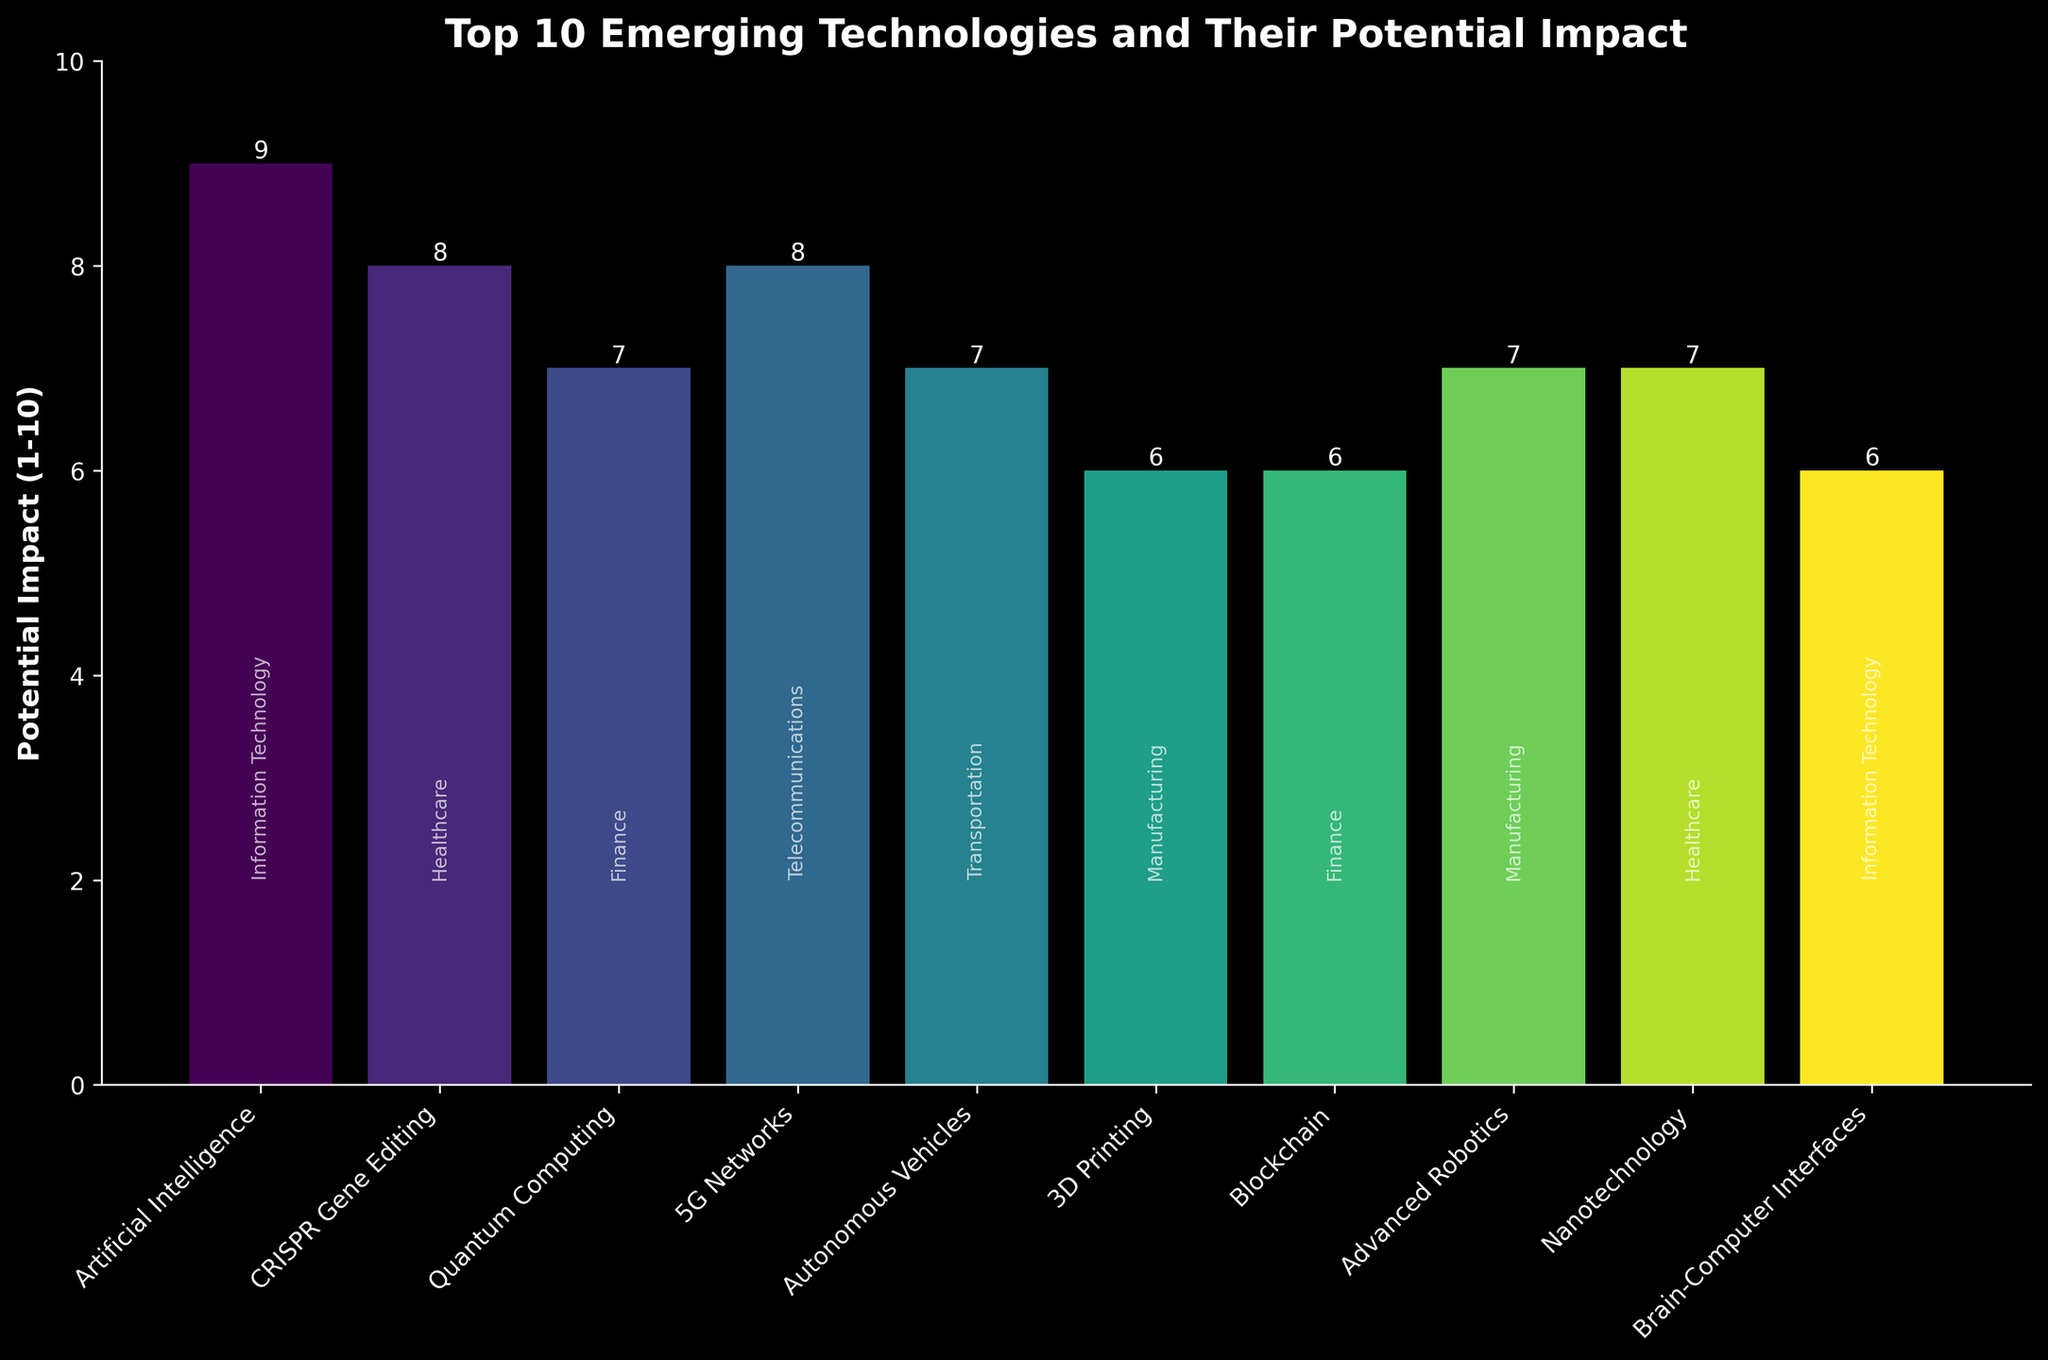Which technology is shown to have the highest potential impact? The figure shows the height of each bar representing the potential impact of each technology. The bar for Artificial Intelligence is the tallest, indicating the highest impact.
Answer: Artificial Intelligence Which primary industry is affected by both the technology with the highest and the lowest impact? To determine this, identify the technology with the highest (Artificial Intelligence) and lowest (3D Printing, Brain-Computer Interfaces, Blockchain) impact from the chart and check the associated industries. "Information Technology" is the industry for Artificial Intelligence and Brain-Computer Interfaces.
Answer: Information Technology What is the difference in potential impact between CRISPR Gene Editing and Quantum Computing? CRISPR Gene Editing has a potential impact value of 8, and Quantum Computing has a value of 7. Therefore, the difference is 8 - 7.
Answer: 1 Which industry appears frequently among the top 10 emerging technologies? The chart labels industries next to each bar. By counting, "Healthcare" appears twice (CRISPR Gene Editing and Nanotechnology) and "Manufacturing" appears twice (3D Printing and Advanced Robotics).
Answer: Healthcare and Manufacturing How many technologies have an impact score of 7? Count the number of bars that have a height of 7. These are Quantum Computing, Autonomous Vehicles, Advanced Robotics, and Nanotechnology.
Answer: 4 What is the average potential impact of all technologies listed? Sum all impact values: 9 (AI) + 8 (CRISPR) + 7 (Quantum Computing) + 8 (5G) + 7 (Autonomous Vehicles) + 6 (3D Printing) + 6 (Blockchain) + 7 (Advanced Robotics) + 7 (Nanotechnology) + 6 (Brain-Computer Interfaces) = 71. There are 10 technologies, so the average is 71/10.
Answer: 7.1 Which industry benefits most from technologies with a potential impact equal to or higher than 8? The technologies with an impact of 8 or 9 are Artificial Intelligence (Information Technology), CRISPR Gene Editing (Healthcare), and 5G Networks (Telecommunications). Each benefits one industry.
Answer: It's a tie between Information Technology, Healthcare, and Telecommunications By how much does the impact of 3D Printing differ from Advanced Robotics? The impact value of 3D Printing is 6, and for Advanced Robotics, it is 7. The difference is 7 - 6.
Answer: 1 